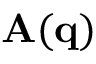Convert formula to latex. <formula><loc_0><loc_0><loc_500><loc_500>A ( q )</formula> 